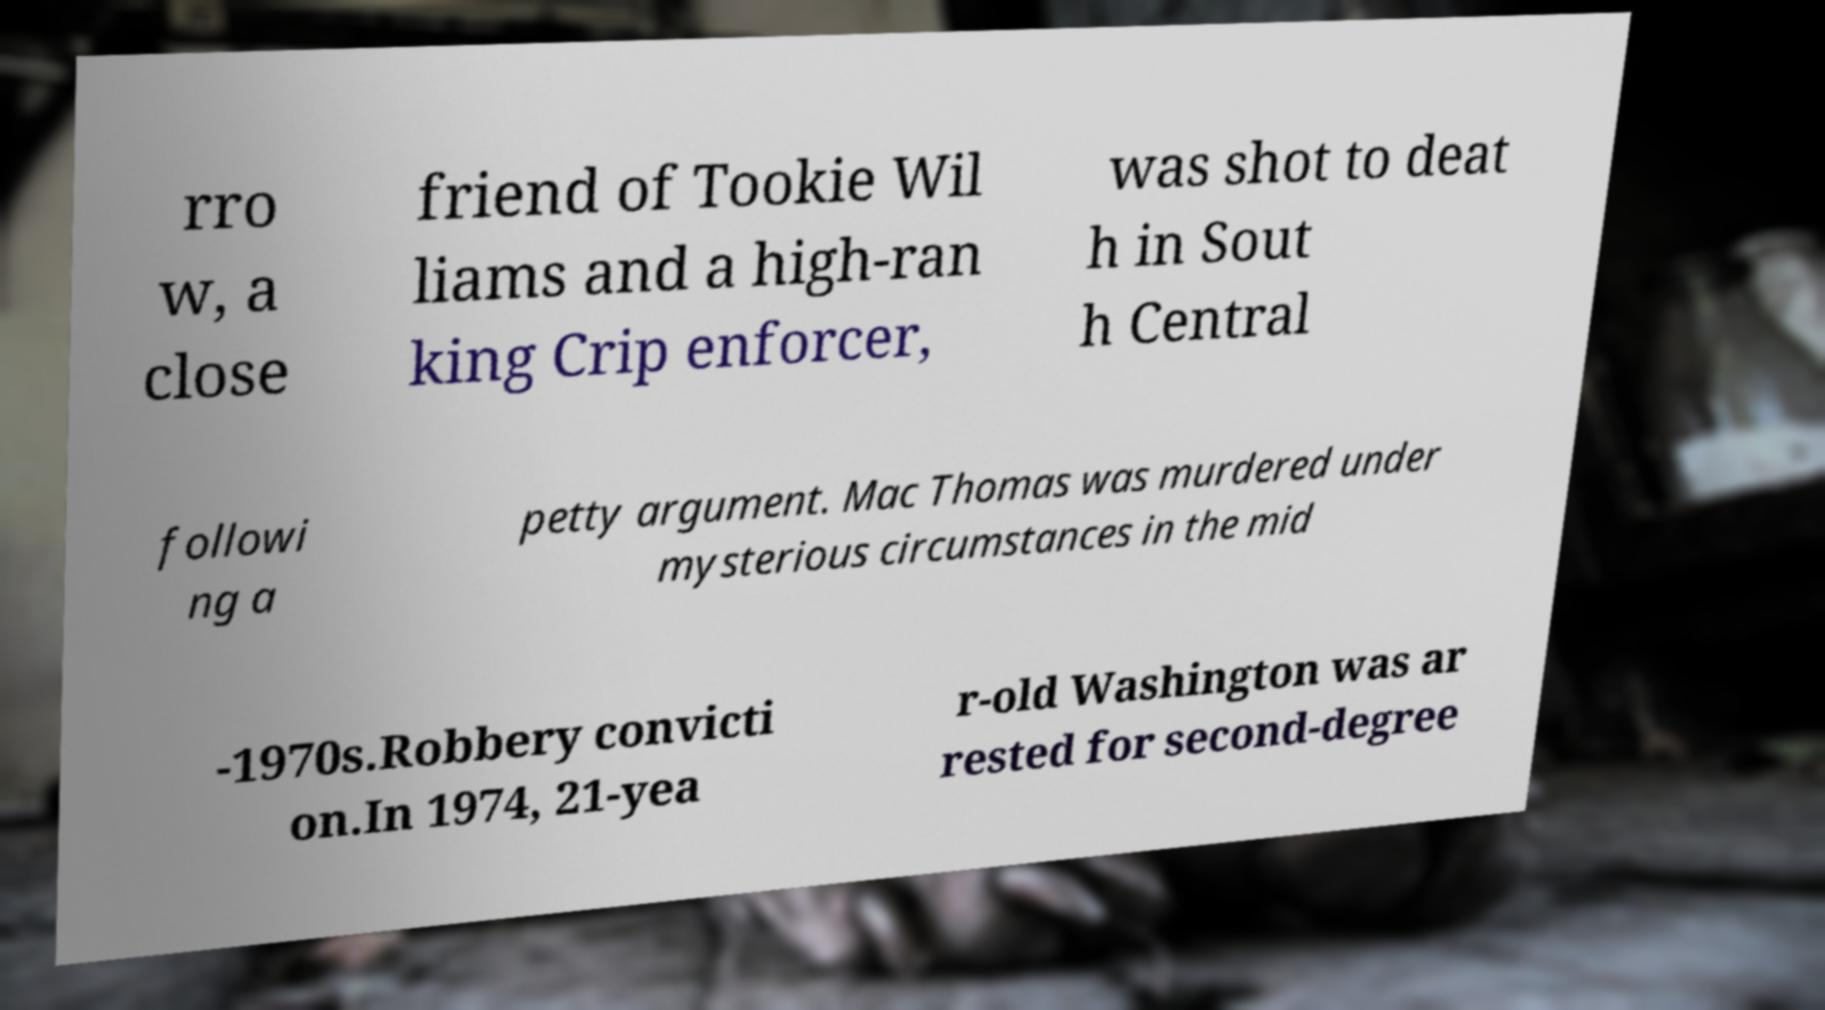Could you assist in decoding the text presented in this image and type it out clearly? rro w, a close friend of Tookie Wil liams and a high-ran king Crip enforcer, was shot to deat h in Sout h Central followi ng a petty argument. Mac Thomas was murdered under mysterious circumstances in the mid -1970s.Robbery convicti on.In 1974, 21-yea r-old Washington was ar rested for second-degree 